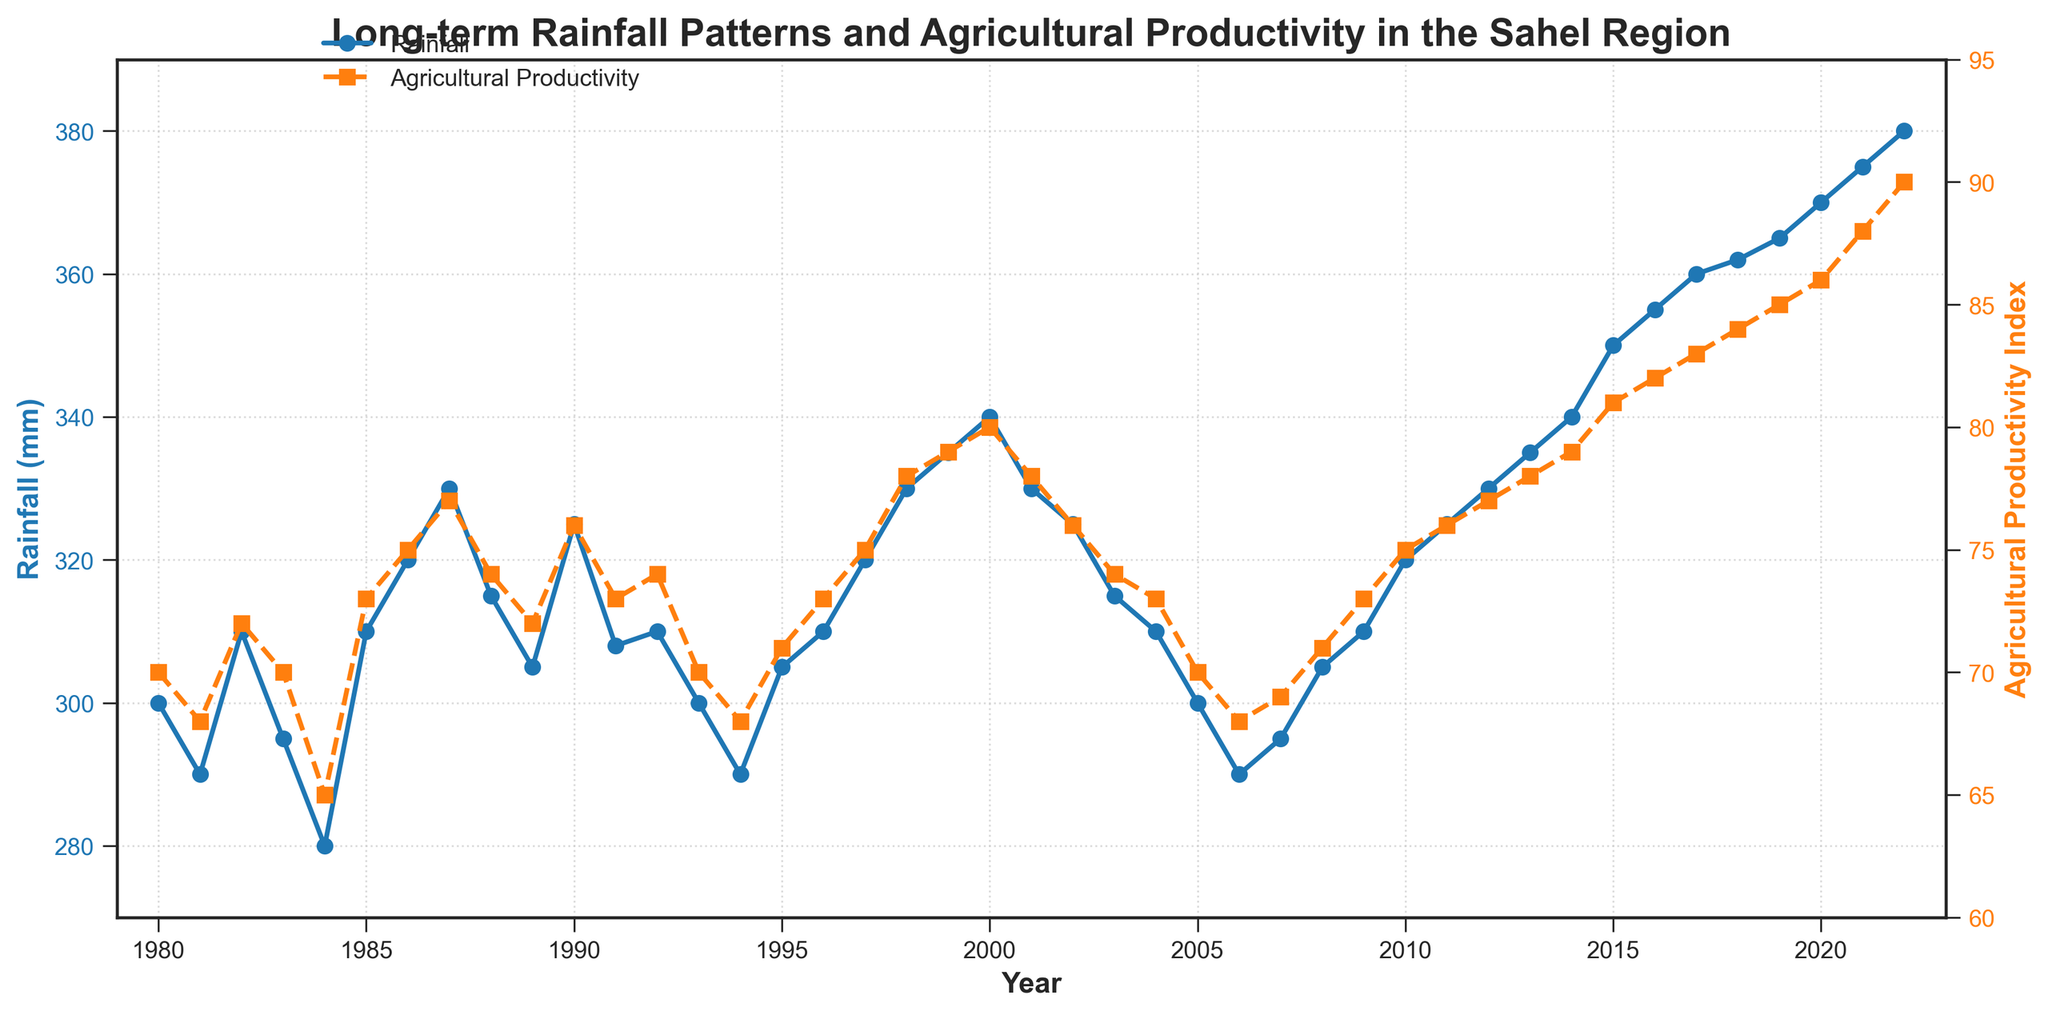What is the title of the plot? The title of the plot is located at the top center of the figure and provides an overview of what the visual data represents.
Answer: Long-term Rainfall Patterns and Agricultural Productivity in the Sahel Region How many years of data are shown in the plot? The x-axis spans from the first year to the last year indicated in the data points. Counting the years from 1980 to 2022 shows 43 data points.
Answer: 43 years What color represents Agricultural Productivity Index in the plot? The Agricultural Productivity Index is represented by the color associated with the secondary y-axis on the right side of the figure. The line and markers for this index are in orange.
Answer: Orange Which year had the highest rainfall? By examining the peaks in the rainfall line (blue line with circles), the highest data point can be identified at year 2022.
Answer: 2022 What is the Agricultural Productivity Index for the year with the highest rainfall? First, we find the highest rainfall year, which is 2022, and then look at the corresponding value on the orange line representing the Agricultural Productivity Index. The index in 2022 is 90.
Answer: 90 Compare the Agricultural Productivity Index between 1984 and 1998. Which year had a higher index? Review the indices for both years by finding the respective markers on the orange line. The index for 1984 is 65, and for 1998, it's 78.
Answer: 1998 Which year experienced the largest increase in rainfall compared to the previous year? By examining year-over-year differences in the blue line, the largest increase from one year to the next can be spotted between 1999 (335 mm) and 2000 (340 mm), an increase of 5 mm.
Answer: 2000 Is there a year when both the rainfall and Agricultural Productivity Index decreased compared to the previous year? Analyze both the blue and orange lines for any year where both values dip below their previous year. In 1981, both rainfall and the index decrease compared to 1980.
Answer: 1981 What is the overall trend in rainfall from 1980 to 2022? Looking at the blue line from start to end, there's a general upward trend from 300 mm in 1980 to 380 mm in 2022, indicating an overall increase in rainfall over the years.
Answer: Upward trend Has the Agricultural Productivity Index ever surpassed 85? If so, which years? By locating the sections of the orange line above the 85 mark on the secondary y-axis, we see that it surpasses 85 during the years 2021 (88) and 2022 (90).
Answer: 2021 and 2022 